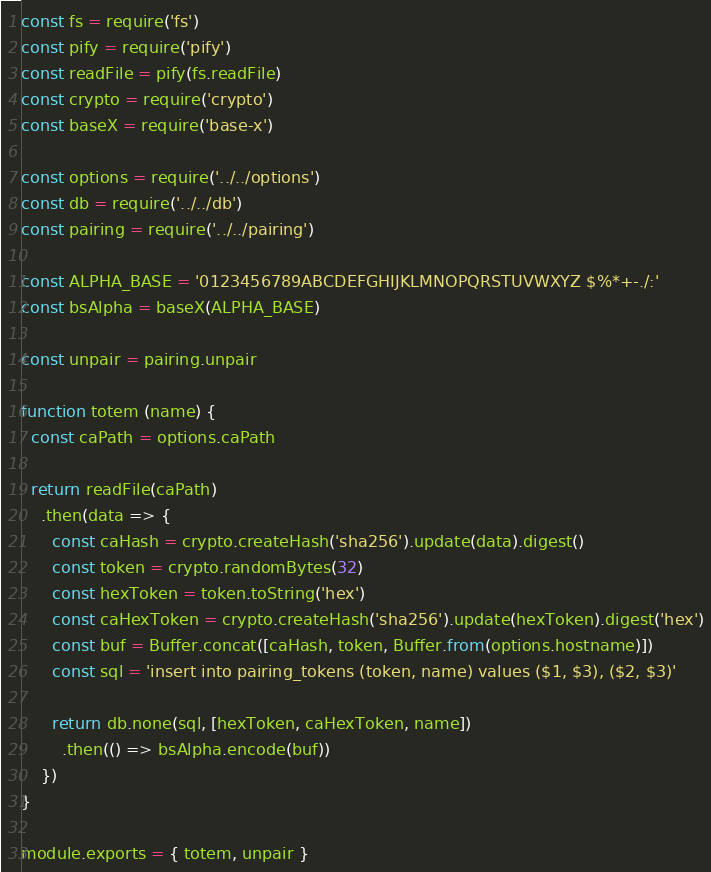<code> <loc_0><loc_0><loc_500><loc_500><_JavaScript_>const fs = require('fs')
const pify = require('pify')
const readFile = pify(fs.readFile)
const crypto = require('crypto')
const baseX = require('base-x')

const options = require('../../options')
const db = require('../../db')
const pairing = require('../../pairing')

const ALPHA_BASE = '0123456789ABCDEFGHIJKLMNOPQRSTUVWXYZ $%*+-./:'
const bsAlpha = baseX(ALPHA_BASE)

const unpair = pairing.unpair

function totem (name) {
  const caPath = options.caPath

  return readFile(caPath)
    .then(data => {
      const caHash = crypto.createHash('sha256').update(data).digest()
      const token = crypto.randomBytes(32)
      const hexToken = token.toString('hex')
      const caHexToken = crypto.createHash('sha256').update(hexToken).digest('hex')
      const buf = Buffer.concat([caHash, token, Buffer.from(options.hostname)])
      const sql = 'insert into pairing_tokens (token, name) values ($1, $3), ($2, $3)'

      return db.none(sql, [hexToken, caHexToken, name])
        .then(() => bsAlpha.encode(buf))
    })
}

module.exports = { totem, unpair }
</code> 